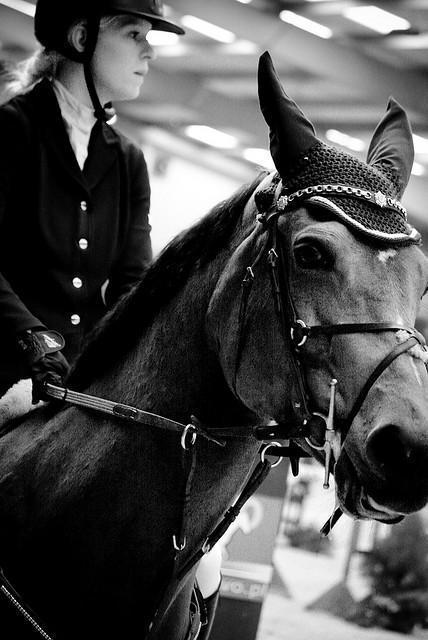How many zebras are here?
Give a very brief answer. 0. 